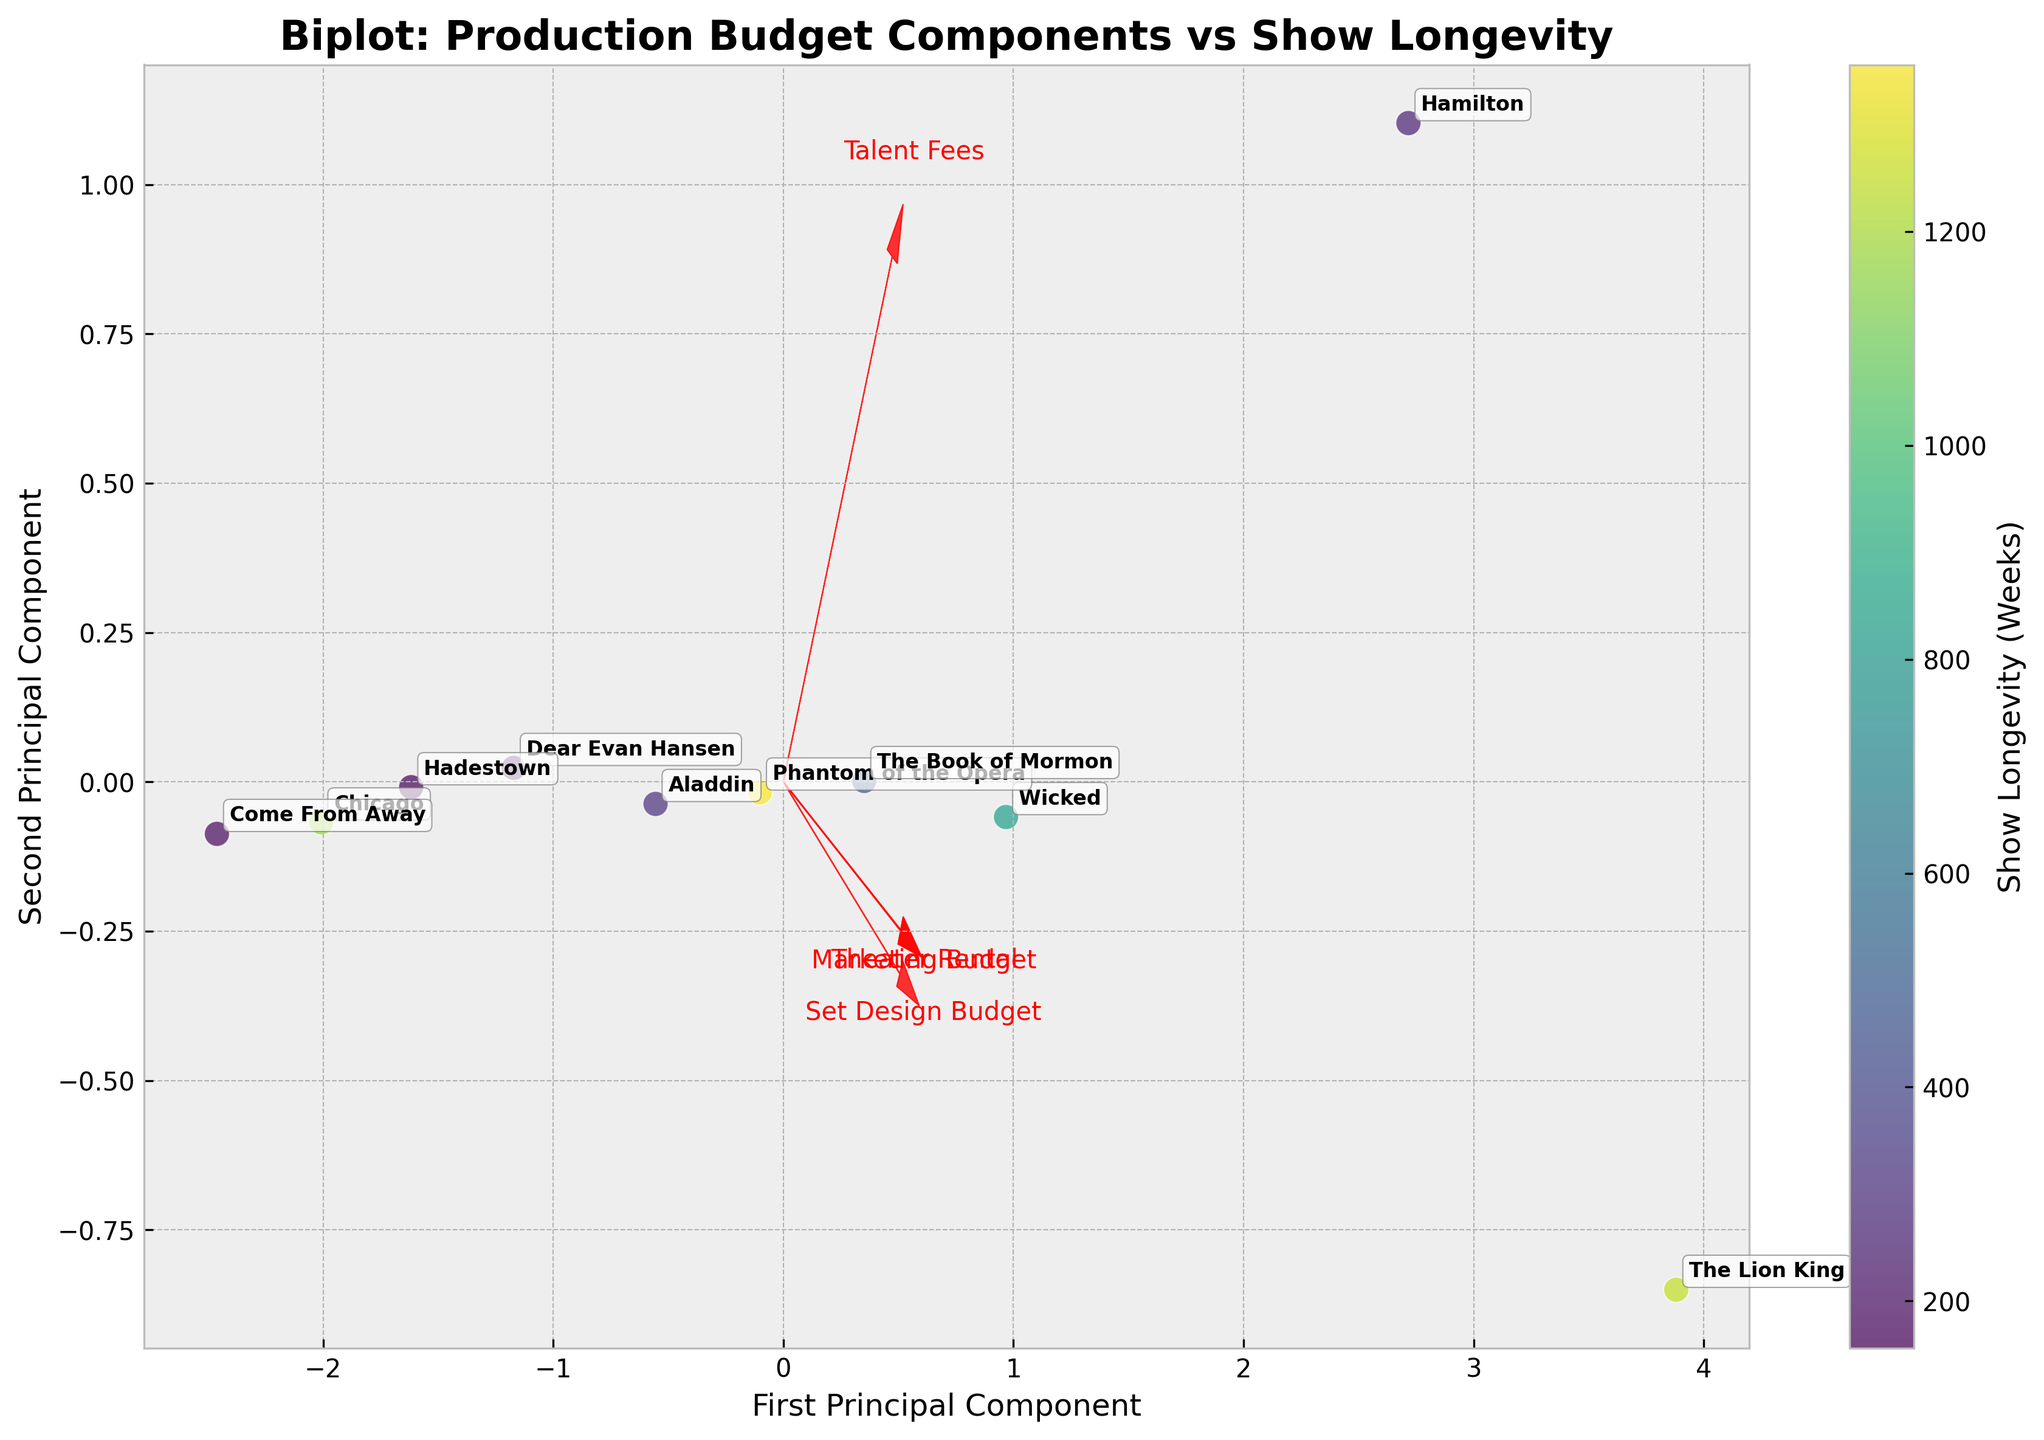What is the title of the biplot? The title of the biplot is given at the top of the figure. Identifying the title helps us understand the primary focus of the visualization.
Answer: Biplot: Production Budget Components vs Show Longevity What do the colors in the biplot represent? The color of each data point on the biplot is determined by the show longevity in weeks. Darker shades indicate longer show longevity, while lighter shades indicate shorter longevity.
Answer: Show longevity in weeks How many production budgets are being analyzed in the biplot? There are four arrows in the biplot, each labeled with a budget component. By counting these arrows, we can determine the number of budgets analyzed.
Answer: Four Which components have the longest vectors? The length of the vectors in the biplot indicates the proportion of the variance in the data explained by each component. The longest vectors have more influence on the principal components.
Answer: Talent Fees and Set Design Budget Which show has the highest importance on the first principal component? By examining the positions of the data points along the horizontal axis (First Principal Component), we can identify which show is furthest along this axis, indicating its importance.
Answer: The Lion King How does Hamilton's position compare between the first and second principal components? Hamilton's data point can be located, and its relative position along the first and second principal components can be assessed. This involves viewing its location in the x (First PC) and y (Second PC) directions.
Answer: Higher on the first PC, lower on the second PC Is there a clear trend between marketing budget and show longevity? By examining the direction and magnitude of the arrow for the Marketing Budget, we can assess how it aligns or contrasts with the color gradient representing show longevity.
Answer: No clear trend Which two budget components appear to be most closely aligned? By examining the arrows' directions in the biplot, we can determine which two budget components have the most similar directions, indicating alignment in the principal component space.
Answer: Talent Fees and Set Design Budget Can you identify the shows with the shortest and longest longevity? By checking the color-coded data points, the shortest longevity show is in the lightest shade, and the longest longevity is in the darkest shade.
Answer: Hadestown (shortest), Phantom of the Opera (longest) Do higher marketing budgets correspond with longer show longevity? Examine the direction of the Marketing Budget arrow in relation to the color gradients along both principal components to see if there's a prevalent trend.
Answer: No direct correlation 